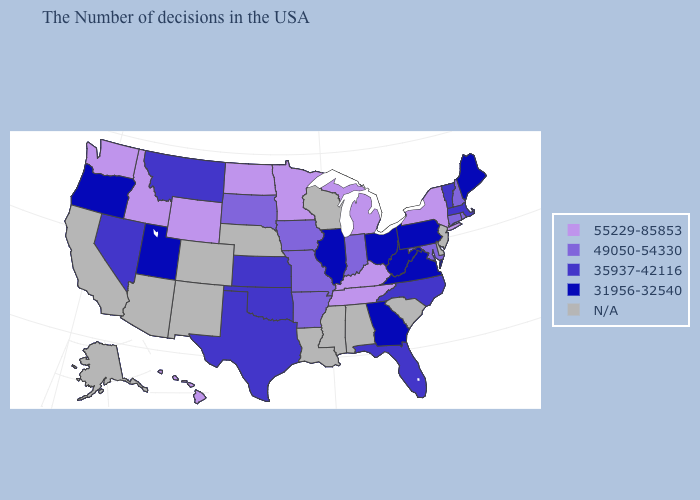Among the states that border Delaware , which have the highest value?
Quick response, please. Maryland. Name the states that have a value in the range 31956-32540?
Answer briefly. Maine, Pennsylvania, Virginia, West Virginia, Ohio, Georgia, Illinois, Utah, Oregon. Which states have the lowest value in the USA?
Keep it brief. Maine, Pennsylvania, Virginia, West Virginia, Ohio, Georgia, Illinois, Utah, Oregon. Does New York have the highest value in the Northeast?
Quick response, please. Yes. What is the highest value in the USA?
Keep it brief. 55229-85853. Does New York have the lowest value in the USA?
Give a very brief answer. No. Which states have the highest value in the USA?
Concise answer only. New York, Michigan, Kentucky, Tennessee, Minnesota, North Dakota, Wyoming, Idaho, Washington, Hawaii. Is the legend a continuous bar?
Be succinct. No. What is the highest value in the West ?
Give a very brief answer. 55229-85853. Does the map have missing data?
Short answer required. Yes. Name the states that have a value in the range 35937-42116?
Quick response, please. Massachusetts, Vermont, North Carolina, Florida, Kansas, Oklahoma, Texas, Montana, Nevada. What is the value of North Dakota?
Write a very short answer. 55229-85853. Name the states that have a value in the range 31956-32540?
Keep it brief. Maine, Pennsylvania, Virginia, West Virginia, Ohio, Georgia, Illinois, Utah, Oregon. Which states have the lowest value in the MidWest?
Give a very brief answer. Ohio, Illinois. 